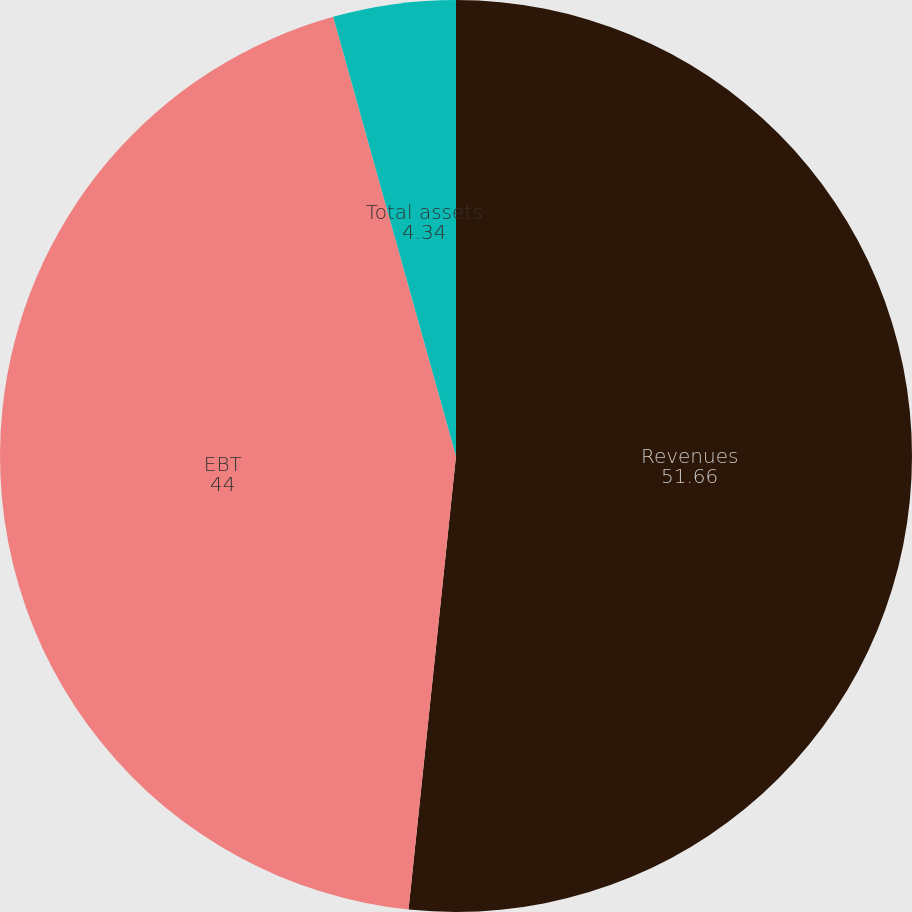<chart> <loc_0><loc_0><loc_500><loc_500><pie_chart><fcel>Revenues<fcel>EBT<fcel>Total assets<nl><fcel>51.66%<fcel>44.0%<fcel>4.34%<nl></chart> 